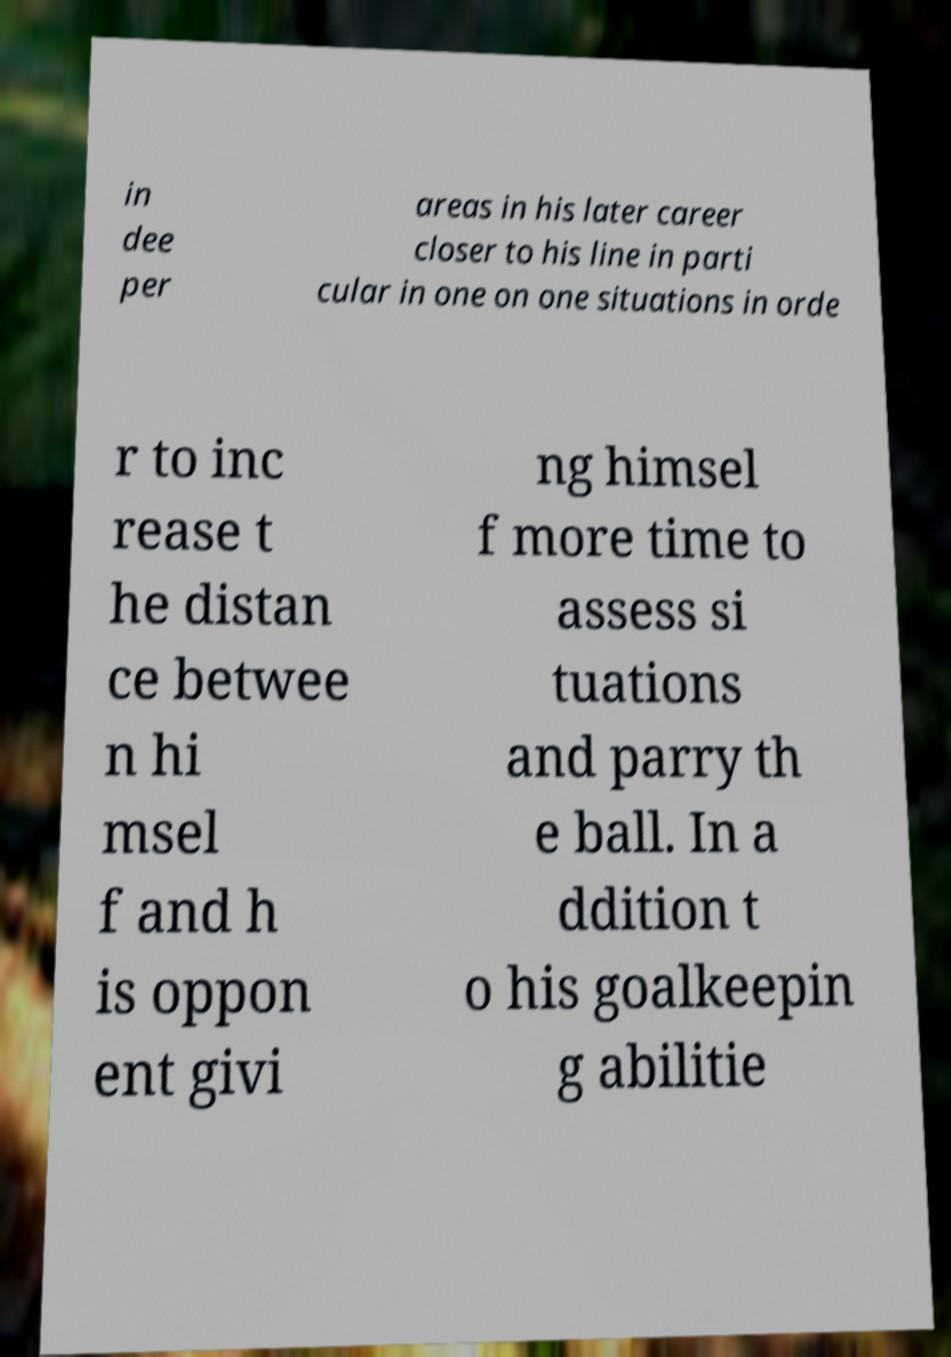What messages or text are displayed in this image? I need them in a readable, typed format. in dee per areas in his later career closer to his line in parti cular in one on one situations in orde r to inc rease t he distan ce betwee n hi msel f and h is oppon ent givi ng himsel f more time to assess si tuations and parry th e ball. In a ddition t o his goalkeepin g abilitie 